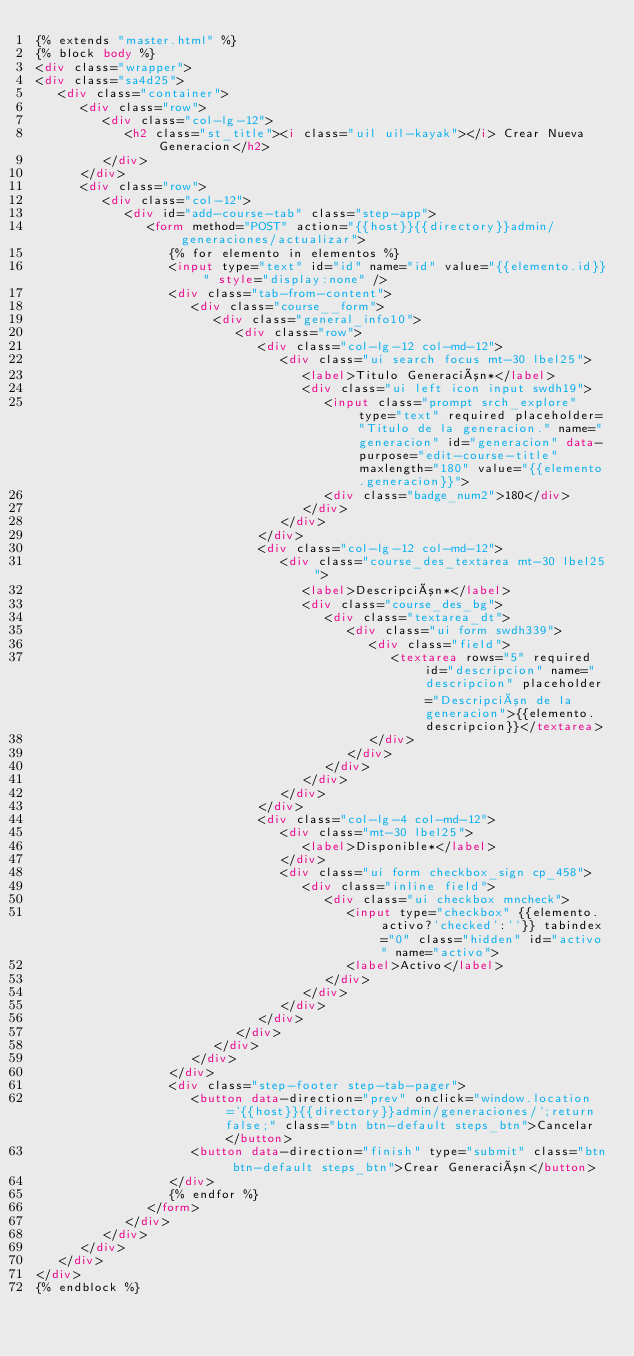<code> <loc_0><loc_0><loc_500><loc_500><_HTML_>{% extends "master.html" %}
{% block body %}
<div class="wrapper">
<div class="sa4d25">
   <div class="container">
      <div class="row">
         <div class="col-lg-12">
            <h2 class="st_title"><i class="uil uil-kayak"></i> Crear Nueva Generacion</h2>
         </div>
      </div>
      <div class="row">
         <div class="col-12">
            <div id="add-course-tab" class="step-app">
               <form method="POST" action="{{host}}{{directory}}admin/generaciones/actualizar">
                  {% for elemento in elementos %}
                  <input type="text" id="id" name="id" value="{{elemento.id}}" style="display:none" />
                  <div class="tab-from-content">
                     <div class="course__form">
                        <div class="general_info10">
                           <div class="row">
                              <div class="col-lg-12 col-md-12">
                                 <div class="ui search focus mt-30 lbel25">
                                    <label>Titulo Generación*</label>
                                    <div class="ui left icon input swdh19">
                                       <input class="prompt srch_explore" type="text" required placeholder="Titulo de la generacion." name="generacion" id="generacion" data-purpose="edit-course-title" maxlength="180" value="{{elemento.generacion}}">
                                       <div class="badge_num2">180</div>
                                    </div>
                                 </div>
                              </div>
                              <div class="col-lg-12 col-md-12">
                                 <div class="course_des_textarea mt-30 lbel25">
                                    <label>Descripción*</label>
                                    <div class="course_des_bg">
                                       <div class="textarea_dt">
                                          <div class="ui form swdh339">
                                             <div class="field">
                                                <textarea rows="5" required id="descripcion" name="descripcion" placeholder="Descripción de la generacion">{{elemento.descripcion}}</textarea>
                                             </div>
                                          </div>
                                       </div>
                                    </div>
                                 </div>
                              </div>
                              <div class="col-lg-4 col-md-12">
                                 <div class="mt-30 lbel25">
                                    <label>Disponible*</label>
                                 </div>
                                 <div class="ui form checkbox_sign cp_458">
                                    <div class="inline field">
                                       <div class="ui checkbox mncheck">
                                          <input type="checkbox" {{elemento.activo?'checked':''}} tabindex="0" class="hidden" id="activo" name="activo">
                                          <label>Activo</label>
                                       </div>
                                    </div>
                                 </div>
                              </div>
                           </div>
                        </div>
                     </div>
                  </div>
                  <div class="step-footer step-tab-pager">
                     <button data-direction="prev" onclick="window.location='{{host}}{{directory}}admin/generaciones/';return false;" class="btn btn-default steps_btn">Cancelar</button>
                     <button data-direction="finish" type="submit" class="btn btn-default steps_btn">Crear Generación</button>
                  </div>
                  {% endfor %}
               </form>
            </div>
         </div>
      </div>
   </div>
</div>
{% endblock %}</code> 